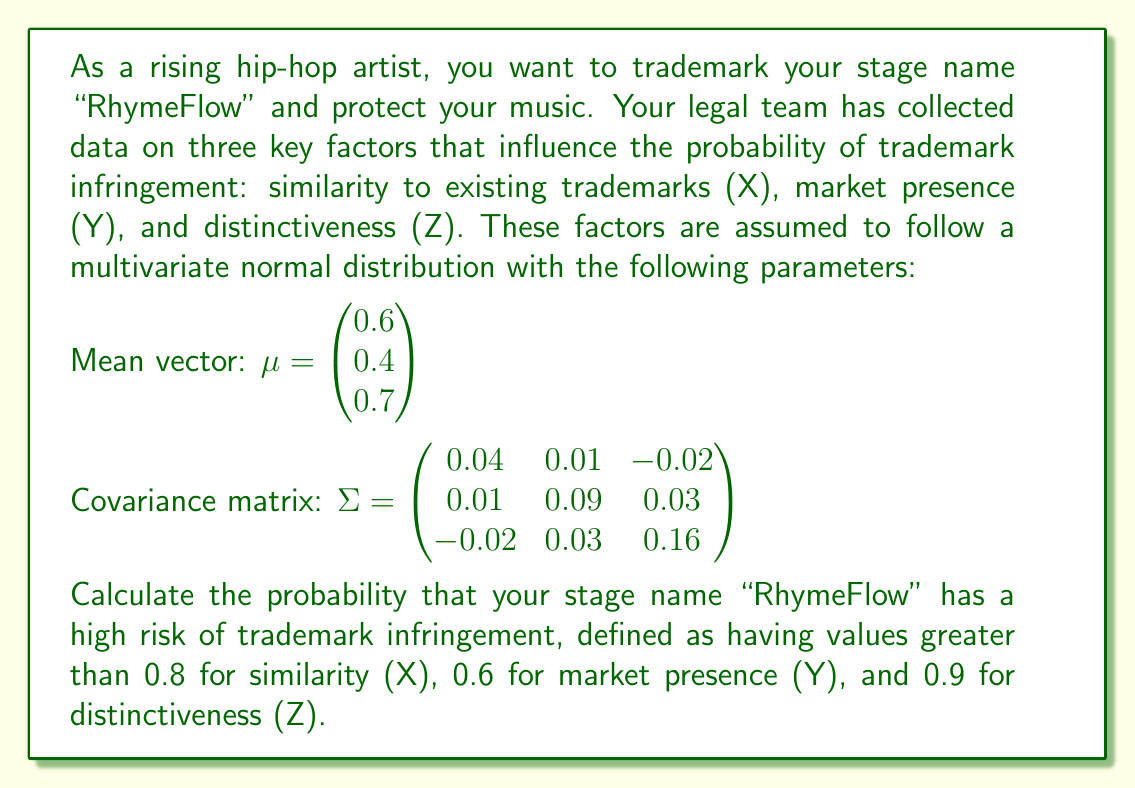Could you help me with this problem? To solve this problem, we need to use the multivariate normal distribution and calculate the probability that X > 0.8, Y > 0.6, and Z > 0.9 simultaneously. This involves the following steps:

1. Standardize the given threshold values:
   Let $a = (0.8, 0.6, 0.9)^T$ be the vector of threshold values.
   Standardized threshold: $z = \Sigma^{-1/2}(a - \mu)$

2. Calculate $\Sigma^{-1/2}$:
   $\Sigma^{-1/2} = \begin{pmatrix} 5.2705 & -0.4098 & 0.5738 \\ -0.4098 & 3.4188 & -0.5328 \\ 0.5738 & -0.5328 & 2.5904 \end{pmatrix}$

3. Calculate $z$:
   $z = \begin{pmatrix} 5.2705 & -0.4098 & 0.5738 \\ -0.4098 & 3.4188 & -0.5328 \\ 0.5738 & -0.5328 & 2.5904 \end{pmatrix} \begin{pmatrix} 0.2 \\ 0.2 \\ 0.2 \end{pmatrix} = \begin{pmatrix} 1.0869 \\ 0.4952 \\ 0.5263 \end{pmatrix}$

4. The probability is then given by:
   $P(X > 0.8, Y > 0.6, Z > 0.9) = 1 - \Phi_3(z)$

   where $\Phi_3$ is the cumulative distribution function of the trivariate standard normal distribution.

5. Using a statistical software or numerical integration method to evaluate $\Phi_3(z)$, we get:
   $\Phi_3(1.0869, 0.4952, 0.5263) \approx 0.8871$

6. Therefore, the probability of high risk of trademark infringement is:
   $P(X > 0.8, Y > 0.6, Z > 0.9) = 1 - 0.8871 \approx 0.1129$
Answer: The probability that the stage name "RhymeFlow" has a high risk of trademark infringement is approximately 0.1129 or 11.29%. 